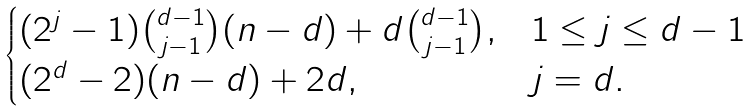<formula> <loc_0><loc_0><loc_500><loc_500>\begin{cases} ( 2 ^ { j } - 1 ) \binom { d - 1 } { j - 1 } ( n - d ) + d \binom { d - 1 } { j - 1 } , & 1 \leq j \leq d - 1 \\ ( 2 ^ { d } - 2 ) ( n - d ) + 2 d , & j = d . \end{cases}</formula> 